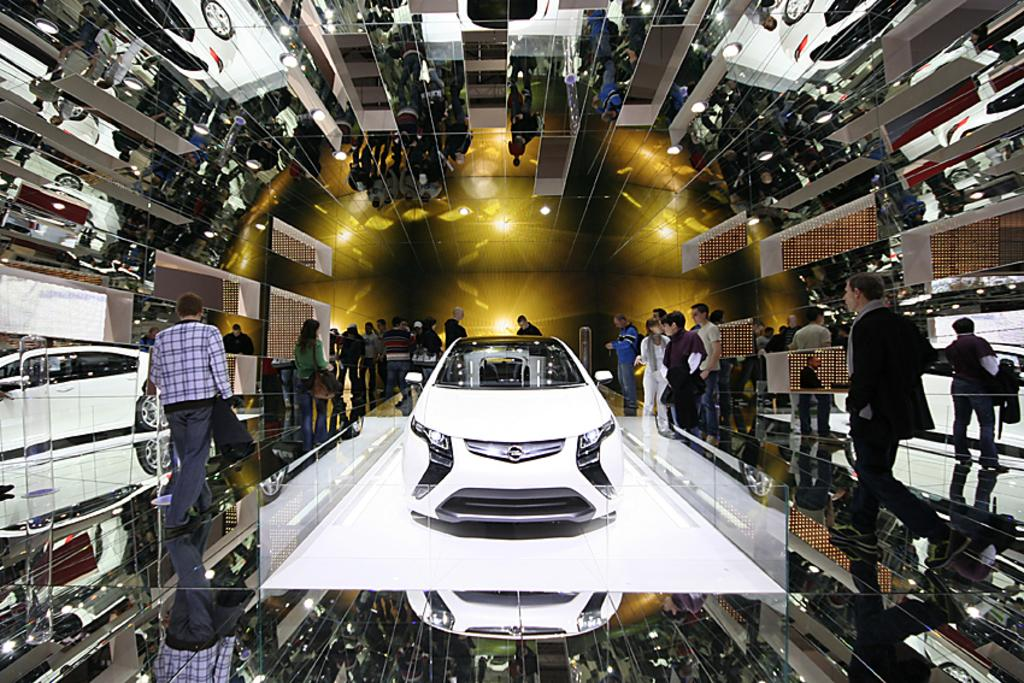What is the main subject of the image? The main subject of the image is a car on a platform. What can be seen in the background of the image? In the background of the image, there are people standing and walking, as well as a glass wall. What type of throat can be seen on the car in the image? There is no throat present on the car in the image, as cars do not have throats. 